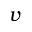Convert formula to latex. <formula><loc_0><loc_0><loc_500><loc_500>v</formula> 